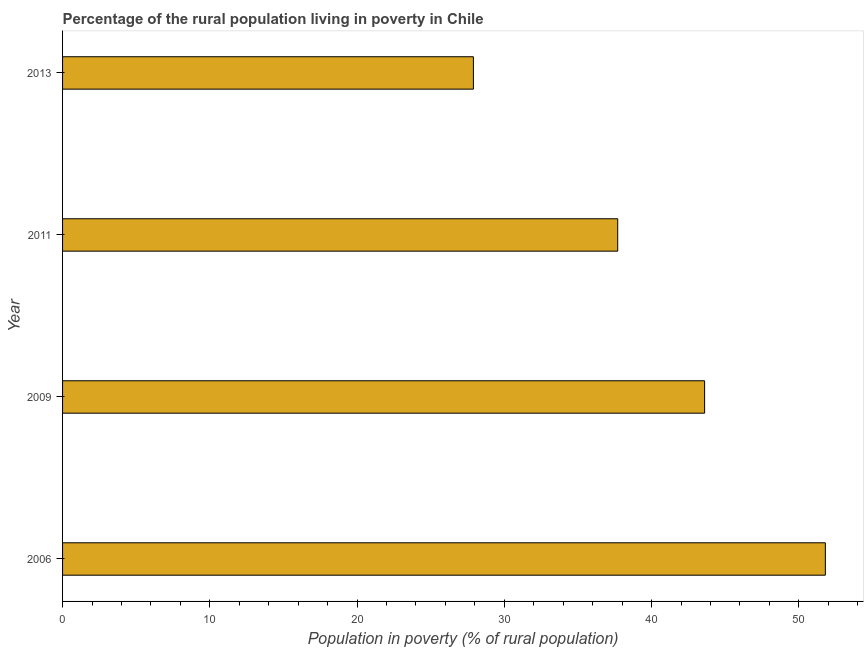Does the graph contain any zero values?
Keep it short and to the point. No. Does the graph contain grids?
Ensure brevity in your answer.  No. What is the title of the graph?
Offer a very short reply. Percentage of the rural population living in poverty in Chile. What is the label or title of the X-axis?
Offer a very short reply. Population in poverty (% of rural population). What is the percentage of rural population living below poverty line in 2011?
Your response must be concise. 37.7. Across all years, what is the maximum percentage of rural population living below poverty line?
Offer a terse response. 51.8. Across all years, what is the minimum percentage of rural population living below poverty line?
Offer a terse response. 27.9. In which year was the percentage of rural population living below poverty line maximum?
Keep it short and to the point. 2006. In which year was the percentage of rural population living below poverty line minimum?
Your response must be concise. 2013. What is the sum of the percentage of rural population living below poverty line?
Provide a short and direct response. 161. What is the difference between the percentage of rural population living below poverty line in 2011 and 2013?
Keep it short and to the point. 9.8. What is the average percentage of rural population living below poverty line per year?
Your answer should be very brief. 40.25. What is the median percentage of rural population living below poverty line?
Your answer should be very brief. 40.65. Do a majority of the years between 2009 and 2011 (inclusive) have percentage of rural population living below poverty line greater than 48 %?
Your response must be concise. No. What is the ratio of the percentage of rural population living below poverty line in 2006 to that in 2013?
Make the answer very short. 1.86. Is the percentage of rural population living below poverty line in 2011 less than that in 2013?
Keep it short and to the point. No. What is the difference between the highest and the lowest percentage of rural population living below poverty line?
Your answer should be very brief. 23.9. How many bars are there?
Provide a short and direct response. 4. Are all the bars in the graph horizontal?
Your answer should be very brief. Yes. How many years are there in the graph?
Give a very brief answer. 4. What is the difference between two consecutive major ticks on the X-axis?
Offer a terse response. 10. What is the Population in poverty (% of rural population) of 2006?
Make the answer very short. 51.8. What is the Population in poverty (% of rural population) of 2009?
Make the answer very short. 43.6. What is the Population in poverty (% of rural population) of 2011?
Provide a short and direct response. 37.7. What is the Population in poverty (% of rural population) in 2013?
Keep it short and to the point. 27.9. What is the difference between the Population in poverty (% of rural population) in 2006 and 2011?
Keep it short and to the point. 14.1. What is the difference between the Population in poverty (% of rural population) in 2006 and 2013?
Your response must be concise. 23.9. What is the difference between the Population in poverty (% of rural population) in 2009 and 2011?
Your answer should be very brief. 5.9. What is the difference between the Population in poverty (% of rural population) in 2009 and 2013?
Your answer should be very brief. 15.7. What is the ratio of the Population in poverty (% of rural population) in 2006 to that in 2009?
Offer a very short reply. 1.19. What is the ratio of the Population in poverty (% of rural population) in 2006 to that in 2011?
Provide a short and direct response. 1.37. What is the ratio of the Population in poverty (% of rural population) in 2006 to that in 2013?
Keep it short and to the point. 1.86. What is the ratio of the Population in poverty (% of rural population) in 2009 to that in 2011?
Provide a short and direct response. 1.16. What is the ratio of the Population in poverty (% of rural population) in 2009 to that in 2013?
Offer a terse response. 1.56. What is the ratio of the Population in poverty (% of rural population) in 2011 to that in 2013?
Your answer should be compact. 1.35. 